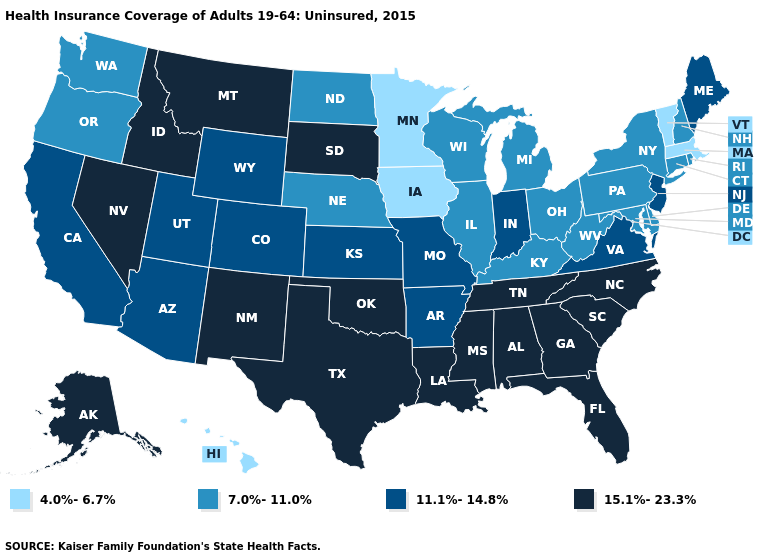Does South Dakota have the highest value in the MidWest?
Keep it brief. Yes. Does Maine have the highest value in the Northeast?
Concise answer only. Yes. Name the states that have a value in the range 11.1%-14.8%?
Concise answer only. Arizona, Arkansas, California, Colorado, Indiana, Kansas, Maine, Missouri, New Jersey, Utah, Virginia, Wyoming. Does Washington have the highest value in the West?
Give a very brief answer. No. Which states hav the highest value in the Northeast?
Short answer required. Maine, New Jersey. What is the value of Michigan?
Be succinct. 7.0%-11.0%. Does Vermont have the lowest value in the Northeast?
Give a very brief answer. Yes. What is the highest value in states that border Indiana?
Short answer required. 7.0%-11.0%. Is the legend a continuous bar?
Concise answer only. No. What is the lowest value in the USA?
Be succinct. 4.0%-6.7%. Does West Virginia have a lower value than Idaho?
Answer briefly. Yes. Among the states that border Maryland , does Pennsylvania have the lowest value?
Be succinct. Yes. Name the states that have a value in the range 7.0%-11.0%?
Concise answer only. Connecticut, Delaware, Illinois, Kentucky, Maryland, Michigan, Nebraska, New Hampshire, New York, North Dakota, Ohio, Oregon, Pennsylvania, Rhode Island, Washington, West Virginia, Wisconsin. What is the value of New Mexico?
Answer briefly. 15.1%-23.3%. What is the value of Idaho?
Be succinct. 15.1%-23.3%. 